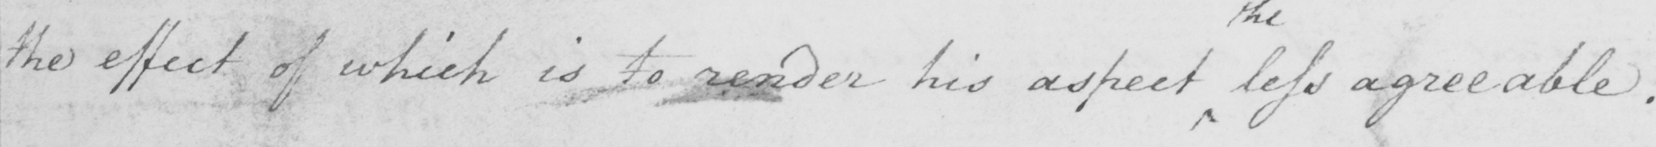Can you tell me what this handwritten text says? the effect of which is to render his aspect less agreeable. 